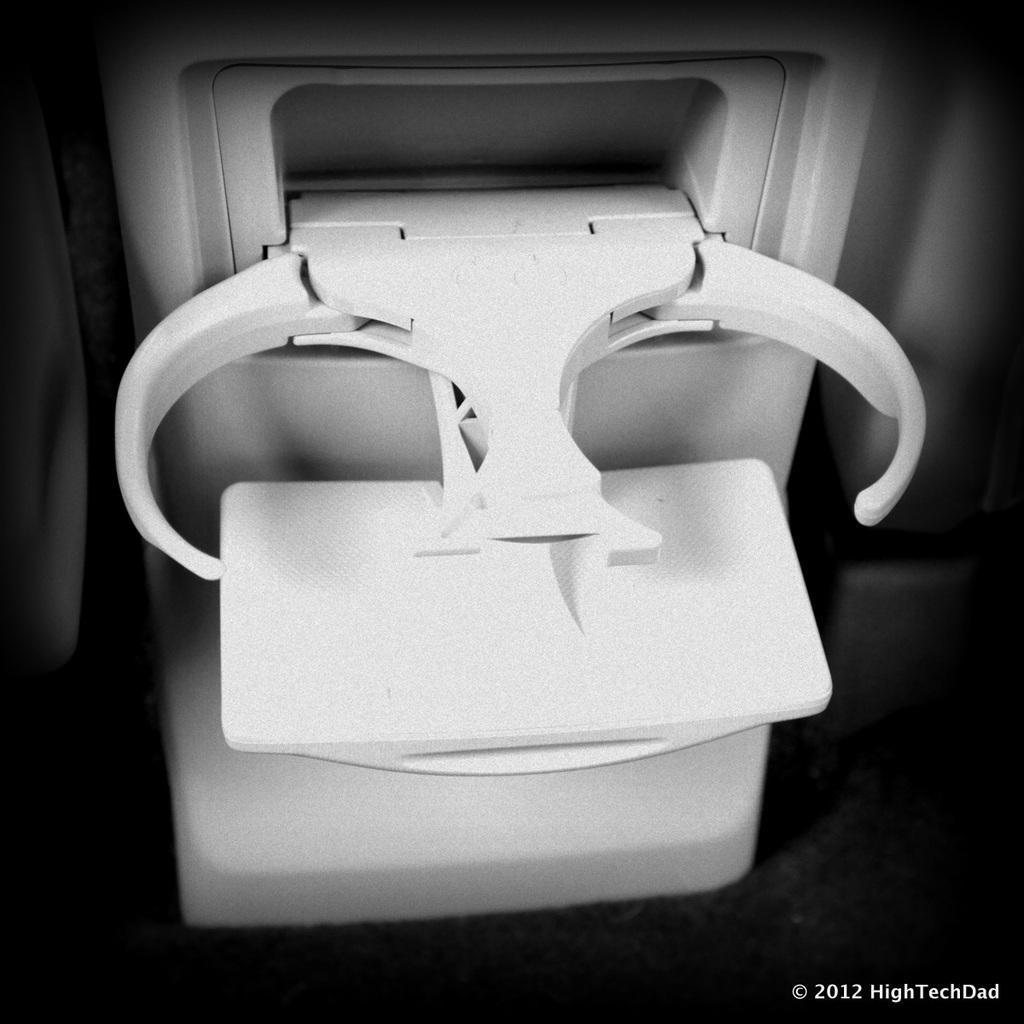What object is partially visible in the image? There is a part of a cup holder in the image. Can you describe the function of the object in the image? The object in the image is a cup holder, which is designed to hold cups or beverages. What type of truck is parked next to the cup holder in the image? There is no truck present in the image; it only shows a part of a cup holder. 